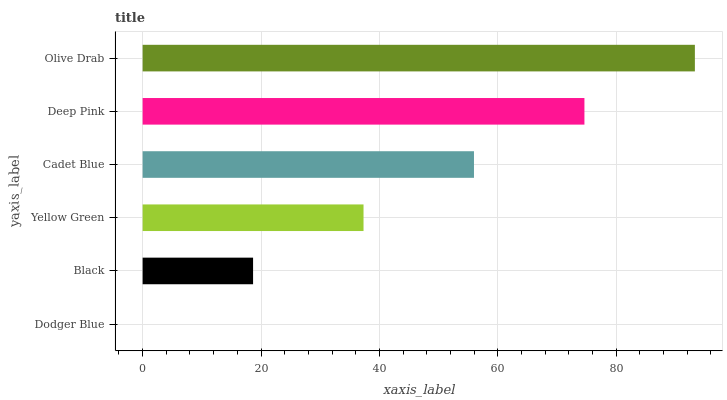Is Dodger Blue the minimum?
Answer yes or no. Yes. Is Olive Drab the maximum?
Answer yes or no. Yes. Is Black the minimum?
Answer yes or no. No. Is Black the maximum?
Answer yes or no. No. Is Black greater than Dodger Blue?
Answer yes or no. Yes. Is Dodger Blue less than Black?
Answer yes or no. Yes. Is Dodger Blue greater than Black?
Answer yes or no. No. Is Black less than Dodger Blue?
Answer yes or no. No. Is Cadet Blue the high median?
Answer yes or no. Yes. Is Yellow Green the low median?
Answer yes or no. Yes. Is Black the high median?
Answer yes or no. No. Is Black the low median?
Answer yes or no. No. 